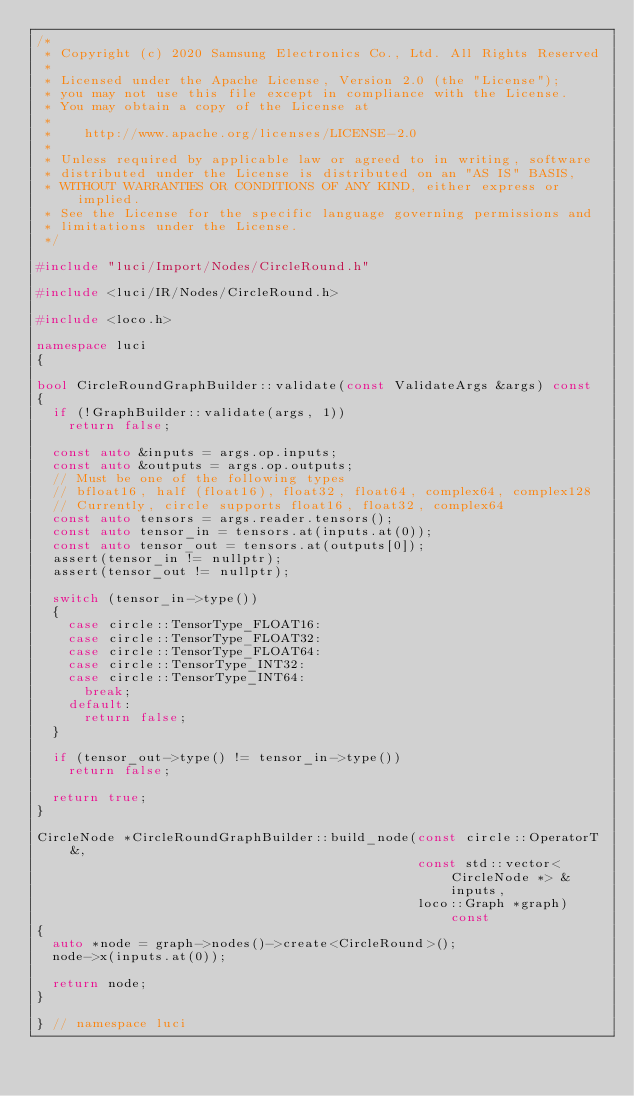Convert code to text. <code><loc_0><loc_0><loc_500><loc_500><_C++_>/*
 * Copyright (c) 2020 Samsung Electronics Co., Ltd. All Rights Reserved
 *
 * Licensed under the Apache License, Version 2.0 (the "License");
 * you may not use this file except in compliance with the License.
 * You may obtain a copy of the License at
 *
 *    http://www.apache.org/licenses/LICENSE-2.0
 *
 * Unless required by applicable law or agreed to in writing, software
 * distributed under the License is distributed on an "AS IS" BASIS,
 * WITHOUT WARRANTIES OR CONDITIONS OF ANY KIND, either express or implied.
 * See the License for the specific language governing permissions and
 * limitations under the License.
 */

#include "luci/Import/Nodes/CircleRound.h"

#include <luci/IR/Nodes/CircleRound.h>

#include <loco.h>

namespace luci
{

bool CircleRoundGraphBuilder::validate(const ValidateArgs &args) const
{
  if (!GraphBuilder::validate(args, 1))
    return false;

  const auto &inputs = args.op.inputs;
  const auto &outputs = args.op.outputs;
  // Must be one of the following types
  // bfloat16, half (float16), float32, float64, complex64, complex128
  // Currently, circle supports float16, float32, complex64
  const auto tensors = args.reader.tensors();
  const auto tensor_in = tensors.at(inputs.at(0));
  const auto tensor_out = tensors.at(outputs[0]);
  assert(tensor_in != nullptr);
  assert(tensor_out != nullptr);

  switch (tensor_in->type())
  {
    case circle::TensorType_FLOAT16:
    case circle::TensorType_FLOAT32:
    case circle::TensorType_FLOAT64:
    case circle::TensorType_INT32:
    case circle::TensorType_INT64:
      break;
    default:
      return false;
  }

  if (tensor_out->type() != tensor_in->type())
    return false;

  return true;
}

CircleNode *CircleRoundGraphBuilder::build_node(const circle::OperatorT &,
                                                const std::vector<CircleNode *> &inputs,
                                                loco::Graph *graph) const
{
  auto *node = graph->nodes()->create<CircleRound>();
  node->x(inputs.at(0));

  return node;
}

} // namespace luci
</code> 